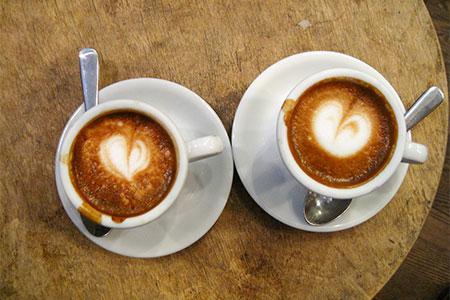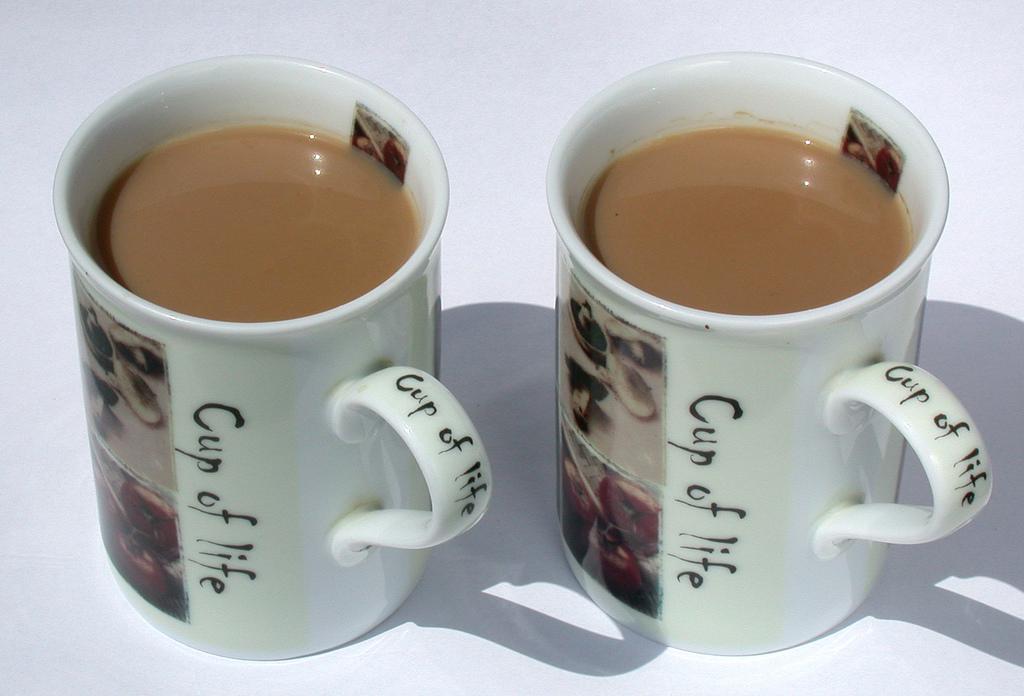The first image is the image on the left, the second image is the image on the right. For the images displayed, is the sentence "The left image features two spoons and two beverages in cups." factually correct? Answer yes or no. Yes. The first image is the image on the left, the second image is the image on the right. Considering the images on both sides, is "Two spoons are visible in the left image." valid? Answer yes or no. Yes. 